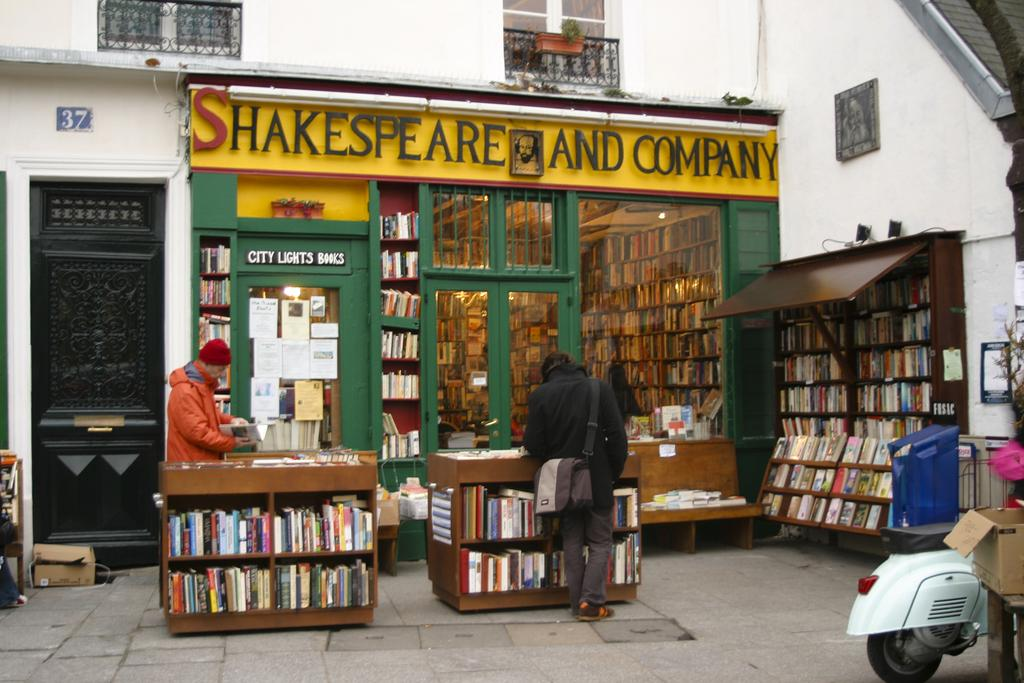<image>
Write a terse but informative summary of the picture. the front entrance to a book store named shakespeare and company. 